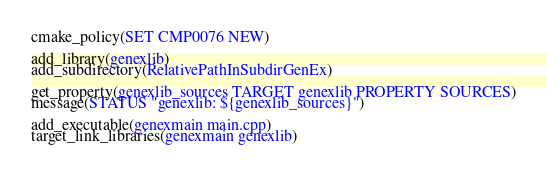Convert code to text. <code><loc_0><loc_0><loc_500><loc_500><_CMake_>cmake_policy(SET CMP0076 NEW)

add_library(genexlib)
add_subdirectory(RelativePathInSubdirGenEx)

get_property(genexlib_sources TARGET genexlib PROPERTY SOURCES)
message(STATUS "genexlib: ${genexlib_sources}")

add_executable(genexmain main.cpp)
target_link_libraries(genexmain genexlib)
</code> 